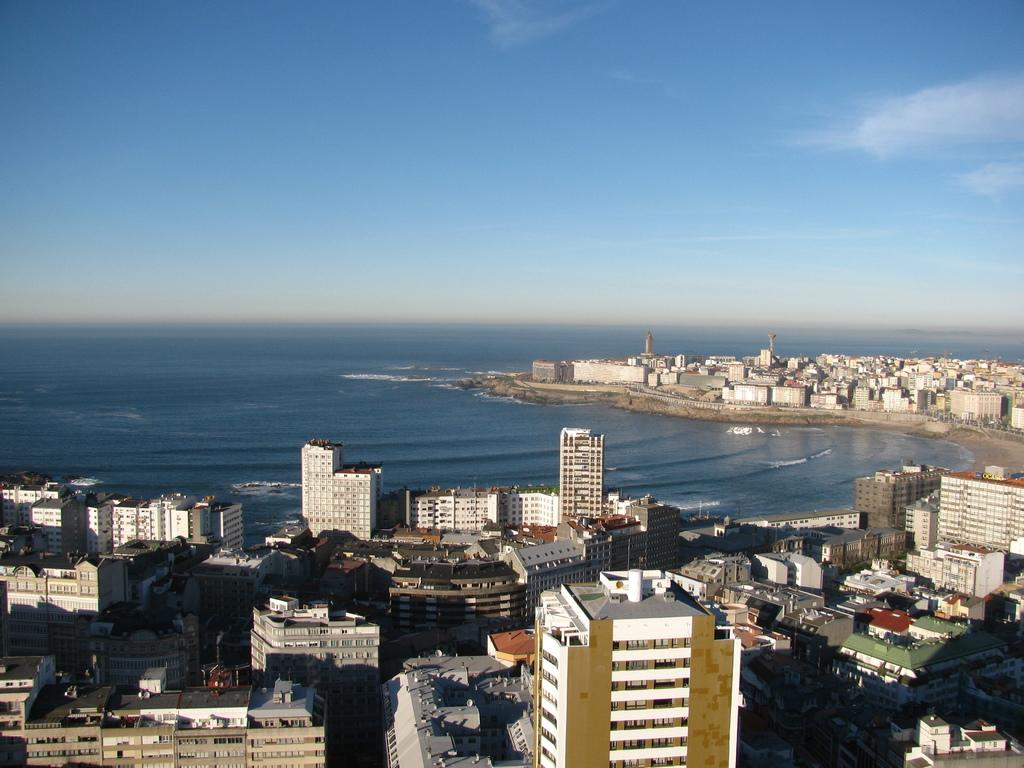What types of structures are present in the image? There are buildings and houses in the image. What can be seen beneath the structures? The ground is visible in the image. Are there any areas where the ground appears different? Some parts of the ground are covered with water. What is visible in the sky in the image? There are clouds in the sky. What year is depicted in the image? The image does not depict a specific year; it is a general scene of buildings, houses, ground, and clouds. Can you see the moon in the image? The moon is not visible in the image; only clouds are present in the sky. 